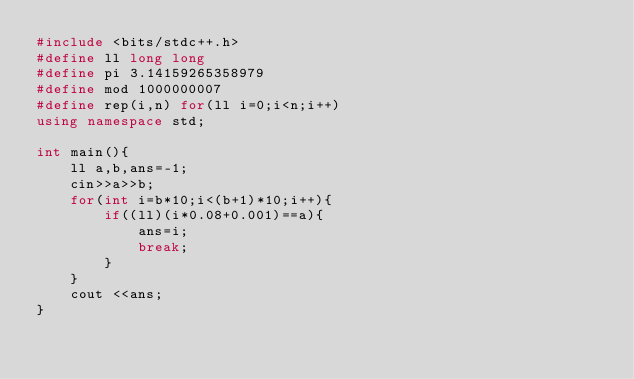<code> <loc_0><loc_0><loc_500><loc_500><_C++_>#include <bits/stdc++.h>
#define ll long long
#define pi 3.14159265358979
#define mod 1000000007
#define rep(i,n) for(ll i=0;i<n;i++)
using namespace std;

int main(){
    ll a,b,ans=-1;
    cin>>a>>b;
    for(int i=b*10;i<(b+1)*10;i++){
        if((ll)(i*0.08+0.001)==a){
            ans=i;
            break;
        }
    }
    cout <<ans;
}</code> 